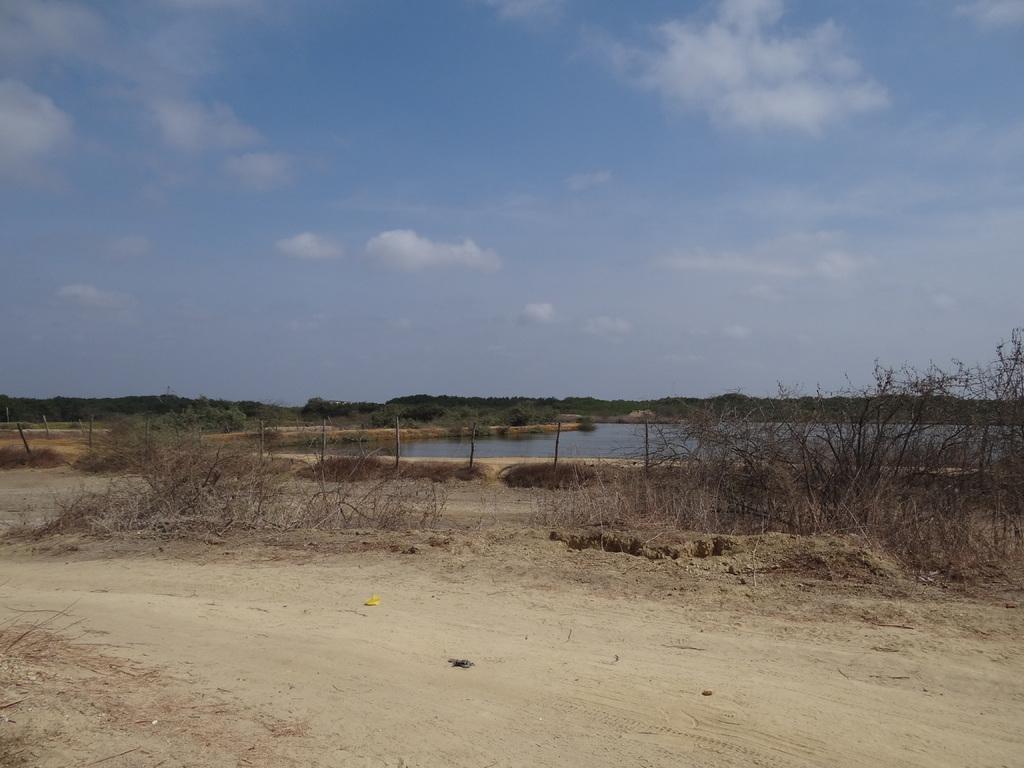How would you summarize this image in a sentence or two? In this picture we can see plants, water, a path, trees and the sky. 